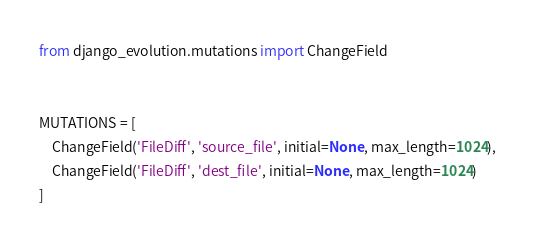<code> <loc_0><loc_0><loc_500><loc_500><_Python_>from django_evolution.mutations import ChangeField


MUTATIONS = [
    ChangeField('FileDiff', 'source_file', initial=None, max_length=1024),
    ChangeField('FileDiff', 'dest_file', initial=None, max_length=1024)
]
</code> 